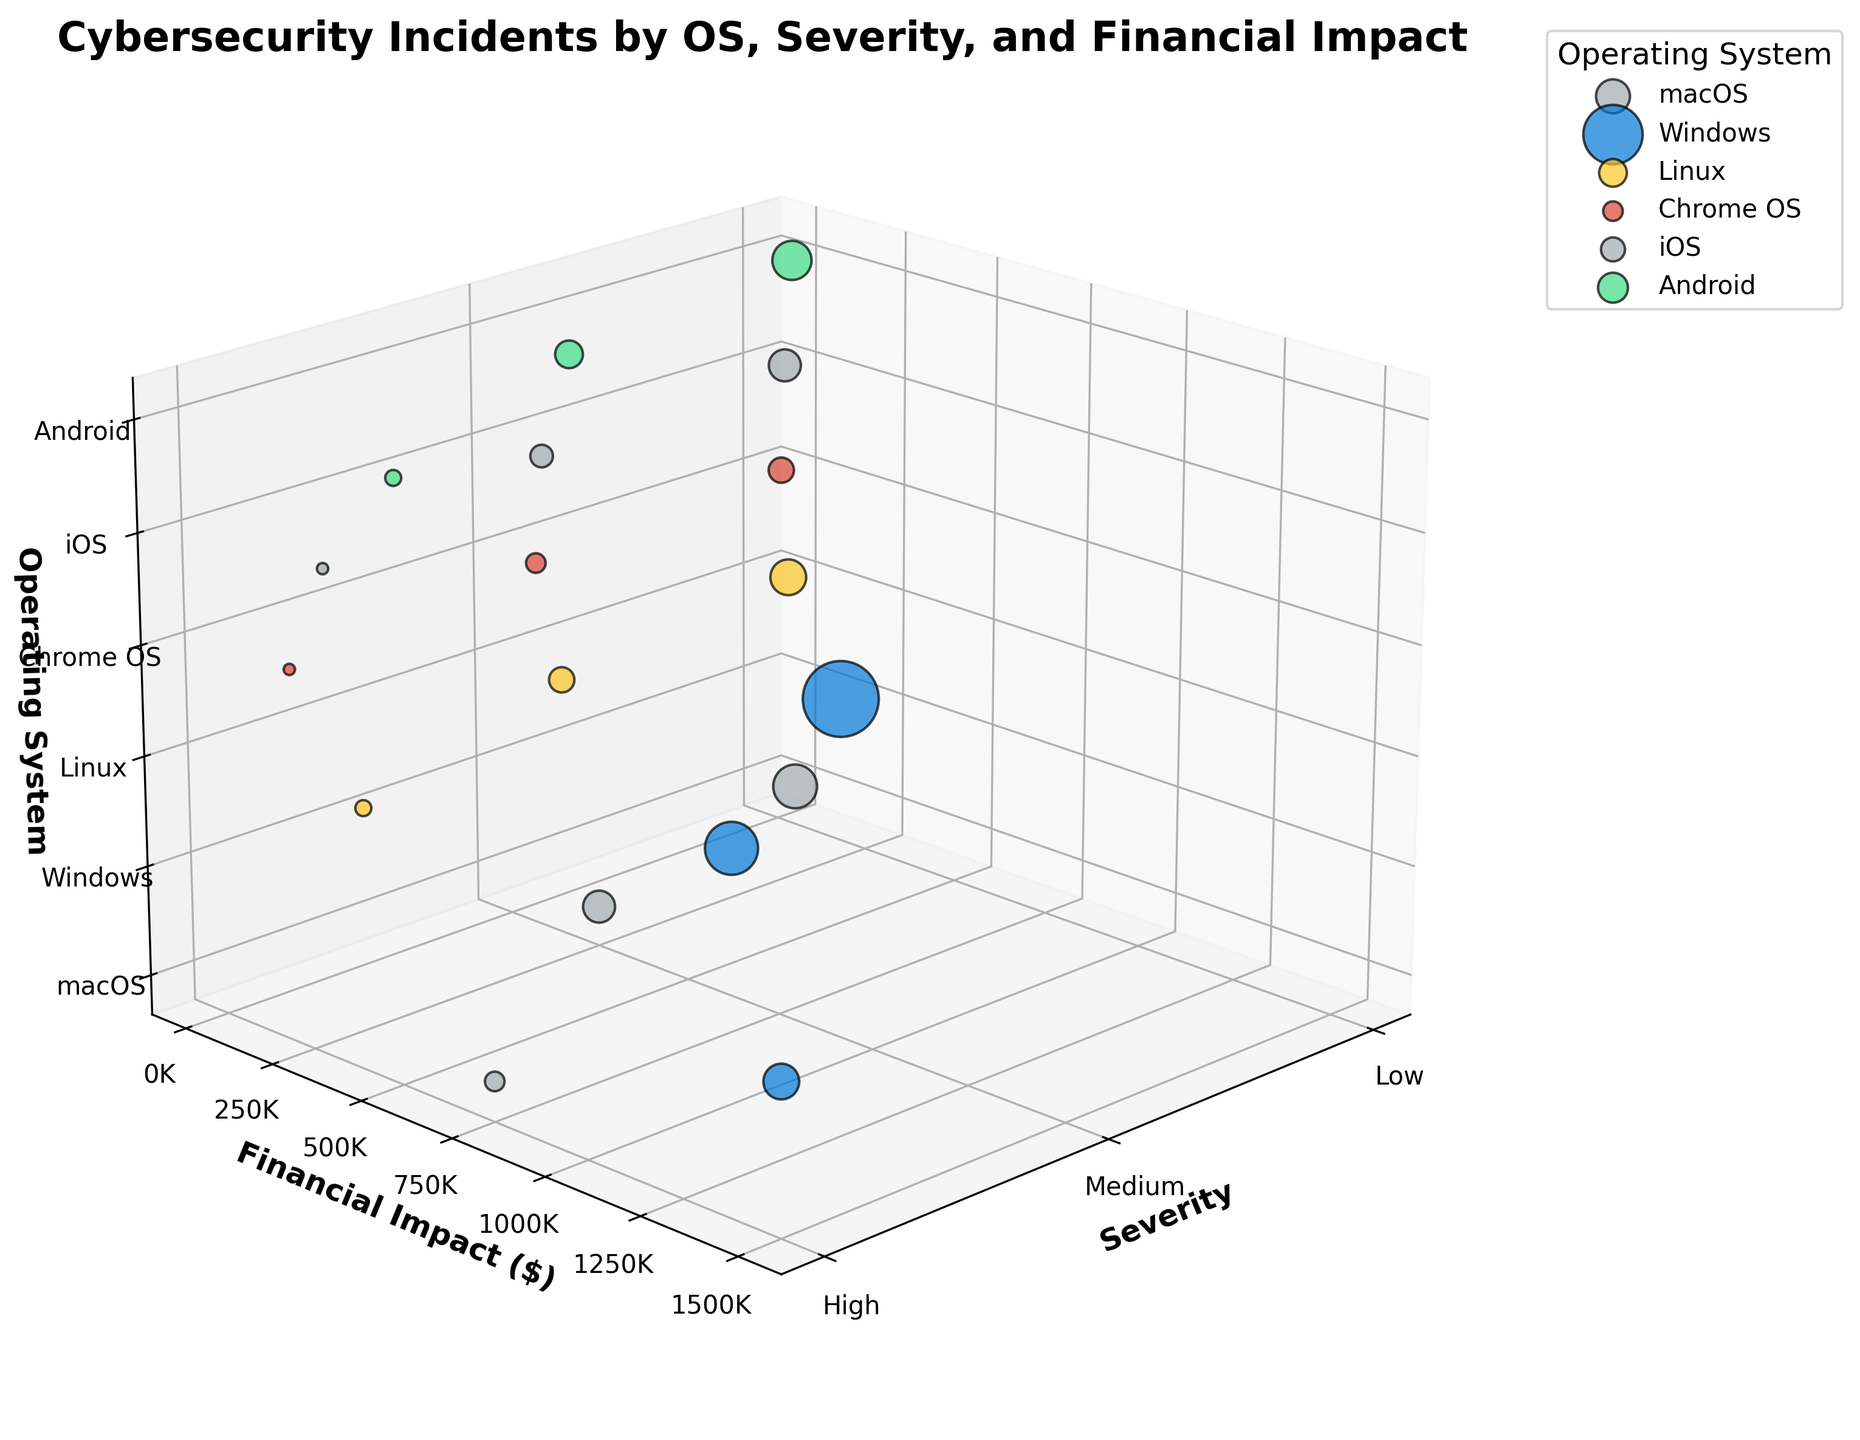How many data points are displayed for macOS? By looking at the number of bubbles for macOS in the plot, we can see there are three data points each corresponding to different severity levels (Low, Medium, High).
Answer: 3 Which operating system has the highest financial impact for high severity incidents? Examine the highest z-positioned bubbles for the High severity category. Windows has the highest financial impact bubble in this category.
Answer: Windows What is the financial impact range for medium severity incidents on Android? Check the y-axis position of the medium severity bubble for Android. The financial impact for Android at medium severity is 180,000 dollars.
Answer: 180,000 Which operating system has the smallest number of incidents for low severity? Look at the size of the bubbles for Low severity incidents and compare them. Chrome OS has the smallest bubble for low severity, indicating the fewest incidents.
Answer: Chrome OS Compare the total number of incidents between Windows and Linux across all severity levels. Which one has more? Sum the number of incidents for each severity level for both Windows and Linux: 
Windows: 45 (Low) + 22 (Medium) + 10 (High) = 77, 
Linux: 10 (Low) + 5 (Medium) + 2 (High) = 17. 
Windows has more incidents.
Answer: Windows What’s the average financial impact for high severity incidents across all operating systems? Find the financial impacts for high severity incidents and calculate their average:
macOS: 750,000,
Windows: 1,500,000,
Linux: 400,000,
Chrome OS: 200,000,
iOS: 300,000,
Android: 500,000.
(750,000 + 1,500,000 + 400,000 + 200,000 + 300,000 + 500,000) / 6 = 608,333.33
Answer: 608,333.33 Which operating system has the most bubbles (data points) with a medium severity level? Look at the bubbles corresponding to medium severity and count the bubbles for each operating system. Windows has the most bubbles with medium severity incidents, followed by macOS and then others.
Answer: Windows 